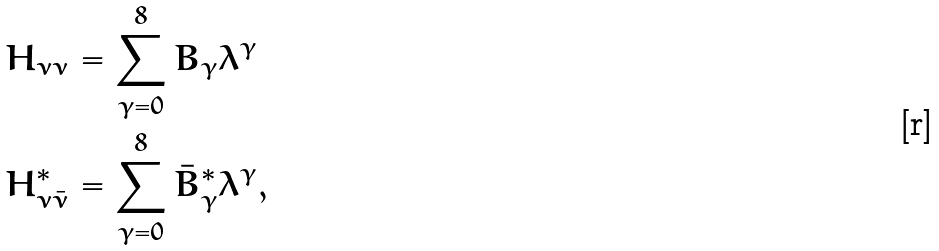<formula> <loc_0><loc_0><loc_500><loc_500>H _ { \nu \nu } & = \sum _ { \gamma = 0 } ^ { 8 } B _ { \gamma } \lambda ^ { \gamma } \\ H _ { \nu \bar { \nu } } ^ { * } & = \sum _ { \gamma = 0 } ^ { 8 } \bar { B } _ { \gamma } ^ { * } \lambda ^ { \gamma } ,</formula> 